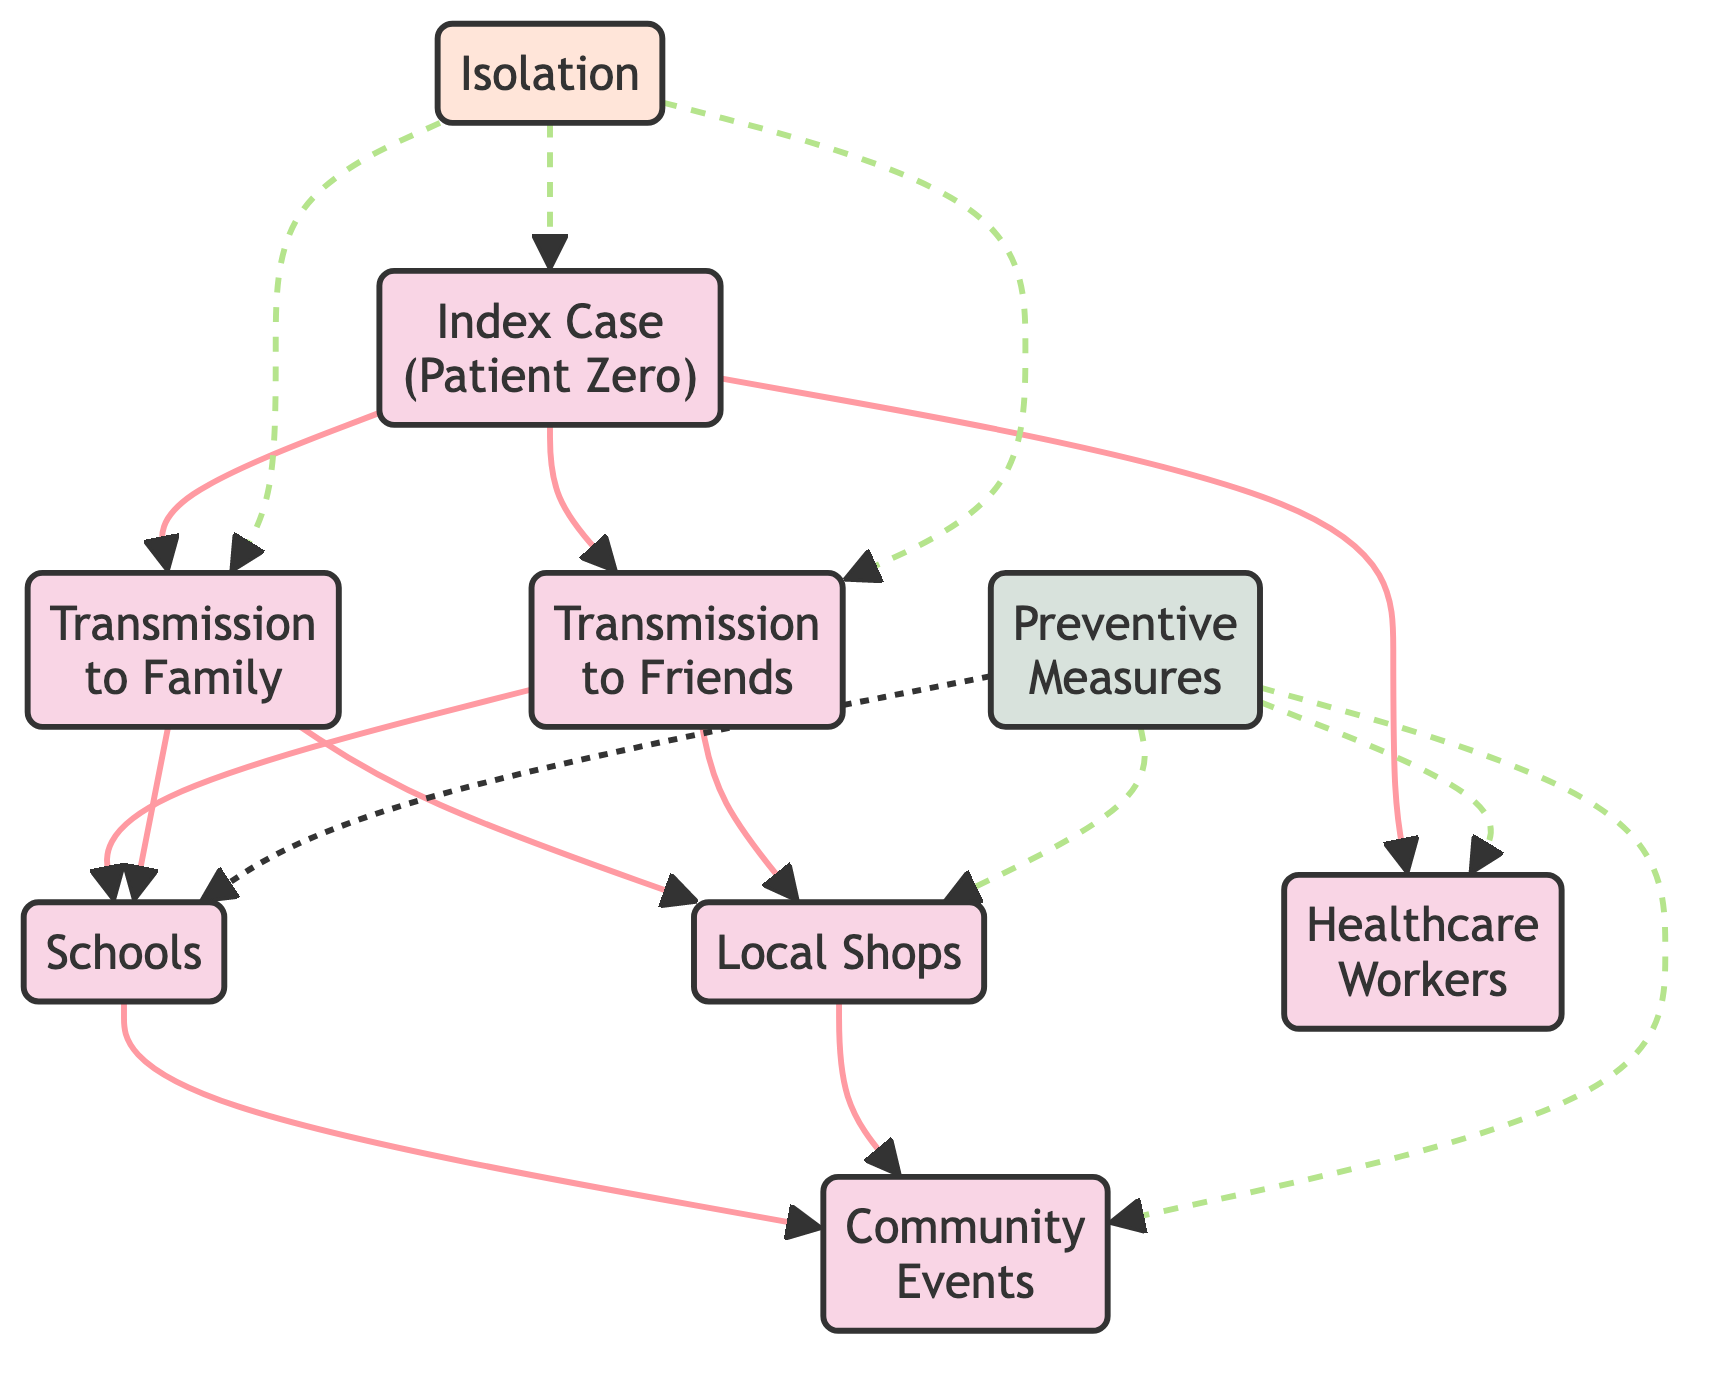What is the 'Index Case' referring to? The 'Index Case' represents the initial patient (Patient Zero) from whom the disease spreads. It forms the starting point of the transmission chain depicted in the diagram.
Answer: Index Case How many distinct pathways lead from the 'Index Case'? The 'Index Case' has three distinct pathways leading to 'Transmission to Family', 'Transmission to Friends', and 'Healthcare Workers', thus indicating three separate directions of potential infection spread.
Answer: 3 Which nodes are directly connected to 'Schools'? The nodes directly connected to 'Schools' are 'Transmission to Friends', 'Transmission to Family', and 'Community Events'. This indicates that both family and friends can transmit the infectious disease to schools, leading to further spread.
Answer: Transmission to Friends, Transmission to Family, Community Events What preventive measures are depicted in the diagram? The 'Preventive Measures' node suggests that precautions need to be taken at various locations, specifically 'Schools', 'Local Shops', 'Community Events', and 'Healthcare Workers', to mitigate the spread of the disease within the community.
Answer: Schools, Local Shops, Community Events, Healthcare Workers How does isolation play a role in the spread of the disease? 'Isolation' is connected to the 'Index Case', 'Transmission to Family', and 'Transmission to Friends', indicating that isolating the infected individuals can stop the transmission of the disease to others in the community.
Answer: Yes What is the impact of community events on disease transmission? 'Community Events' are positioned as a consequence of interactions via 'Schools' and 'Local Shops', showing that they are potential hot spots for the spread of the infection if participants are not careful.
Answer: Potential hot spots Which type of connections are indicated for 'Preventive Measures'? 'Preventive Measures' show dotted lines, indicating indirect effects on preventing disease transmission. This suggests that while these measures are important, they are not directly stopping the transmission routes but are rather preventive efforts at key locations.
Answer: Dotted lines What connections are depicted from 'Transmission to Friends' node? The 'Transmission to Friends' node has connections leading to 'Schools', 'Local Shops', and it also ties into 'Healthcare Workers', indicating that friends can spread the infection in multiple community settings.
Answer: Schools, Local Shops, Healthcare Workers How does 'Transmission to Family' relate to the spread of infection? 'Transmission to Family' directly connects to both 'Schools' and 'Local Shops', suggesting that family interactions can lead to exposure and infection spread in community spaces where children go and shop where families might gather.
Answer: Spreads through Schools and Local Shops 